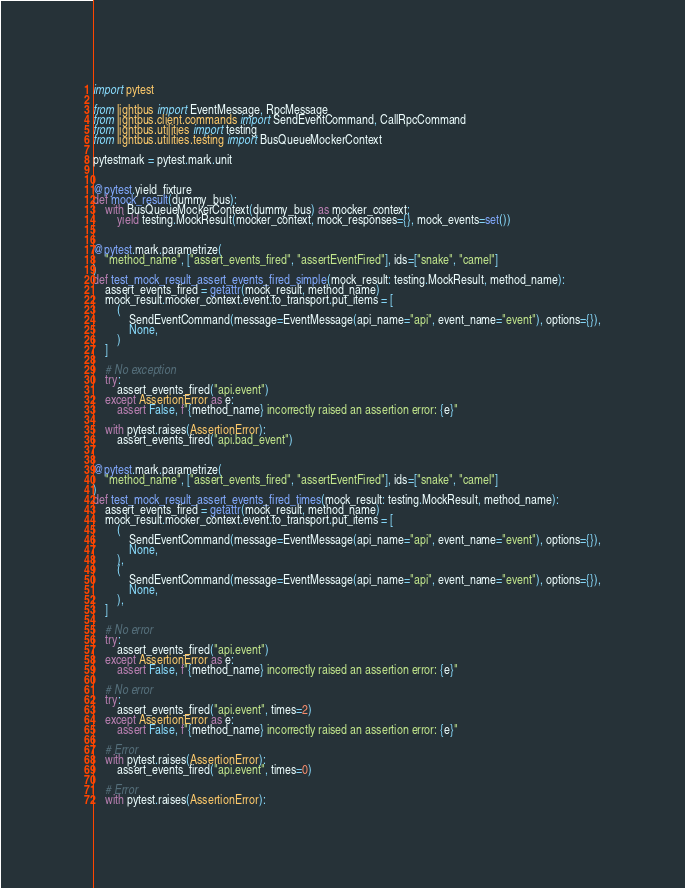Convert code to text. <code><loc_0><loc_0><loc_500><loc_500><_Python_>import pytest

from lightbus import EventMessage, RpcMessage
from lightbus.client.commands import SendEventCommand, CallRpcCommand
from lightbus.utilities import testing
from lightbus.utilities.testing import BusQueueMockerContext

pytestmark = pytest.mark.unit


@pytest.yield_fixture
def mock_result(dummy_bus):
    with BusQueueMockerContext(dummy_bus) as mocker_context:
        yield testing.MockResult(mocker_context, mock_responses={}, mock_events=set())


@pytest.mark.parametrize(
    "method_name", ["assert_events_fired", "assertEventFired"], ids=["snake", "camel"]
)
def test_mock_result_assert_events_fired_simple(mock_result: testing.MockResult, method_name):
    assert_events_fired = getattr(mock_result, method_name)
    mock_result.mocker_context.event.to_transport.put_items = [
        (
            SendEventCommand(message=EventMessage(api_name="api", event_name="event"), options={}),
            None,
        )
    ]

    # No exception
    try:
        assert_events_fired("api.event")
    except AssertionError as e:
        assert False, f"{method_name} incorrectly raised an assertion error: {e}"

    with pytest.raises(AssertionError):
        assert_events_fired("api.bad_event")


@pytest.mark.parametrize(
    "method_name", ["assert_events_fired", "assertEventFired"], ids=["snake", "camel"]
)
def test_mock_result_assert_events_fired_times(mock_result: testing.MockResult, method_name):
    assert_events_fired = getattr(mock_result, method_name)
    mock_result.mocker_context.event.to_transport.put_items = [
        (
            SendEventCommand(message=EventMessage(api_name="api", event_name="event"), options={}),
            None,
        ),
        (
            SendEventCommand(message=EventMessage(api_name="api", event_name="event"), options={}),
            None,
        ),
    ]

    # No error
    try:
        assert_events_fired("api.event")
    except AssertionError as e:
        assert False, f"{method_name} incorrectly raised an assertion error: {e}"

    # No error
    try:
        assert_events_fired("api.event", times=2)
    except AssertionError as e:
        assert False, f"{method_name} incorrectly raised an assertion error: {e}"

    # Error
    with pytest.raises(AssertionError):
        assert_events_fired("api.event", times=0)

    # Error
    with pytest.raises(AssertionError):</code> 